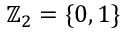<formula> <loc_0><loc_0><loc_500><loc_500>{ \mathbb { Z } } _ { 2 } = \{ 0 , 1 \}</formula> 